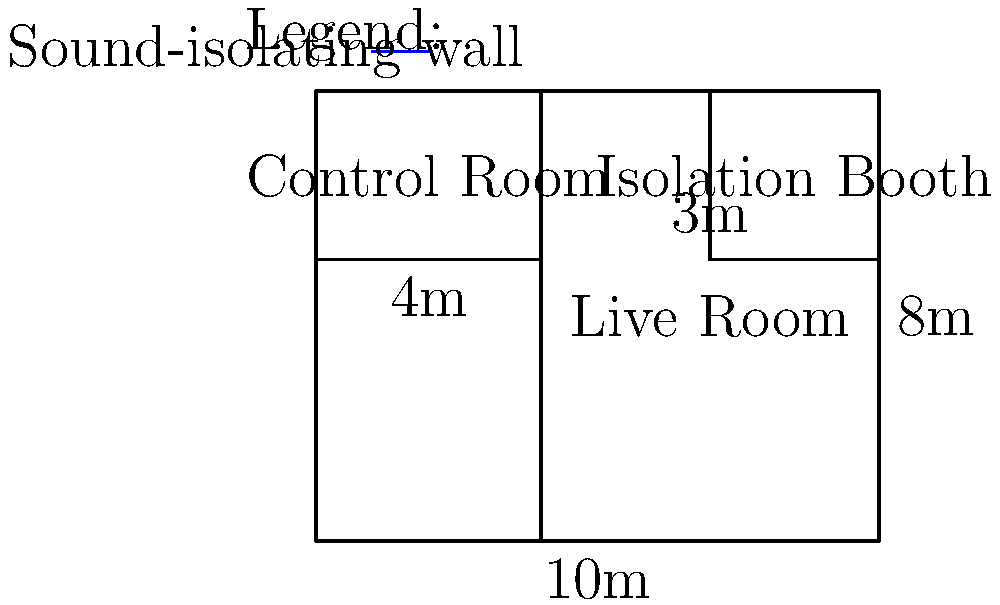In the structural blueprint of a recording studio shown above, what is the total floor area of the live room in square meters? To calculate the floor area of the live room, we need to follow these steps:

1. Identify the dimensions of the live room:
   - The width of the entire studio is 10m
   - The control room takes up 4m of the width
   - So, the width of the live room is 10m - 4m = 6m
   - The height of the studio is 8m

2. Calculate the area of the rectangular live room:
   - Area = width × height
   - Area = 6m × 8m = 48m²

3. Consider the isolation booth:
   - The isolation booth is part of the live room space
   - Its dimensions are 3m × 3m (3m wide, and from the top of the layout to the dividing line)
   - Area of the isolation booth = 3m × 3m = 9m²

4. The total floor area of the live room includes the main space and the isolation booth:
   - Total area = Main live room area + Isolation booth area
   - Total area = 48m² + 9m² = 57m²

Therefore, the total floor area of the live room is 57 square meters.
Answer: 57m² 